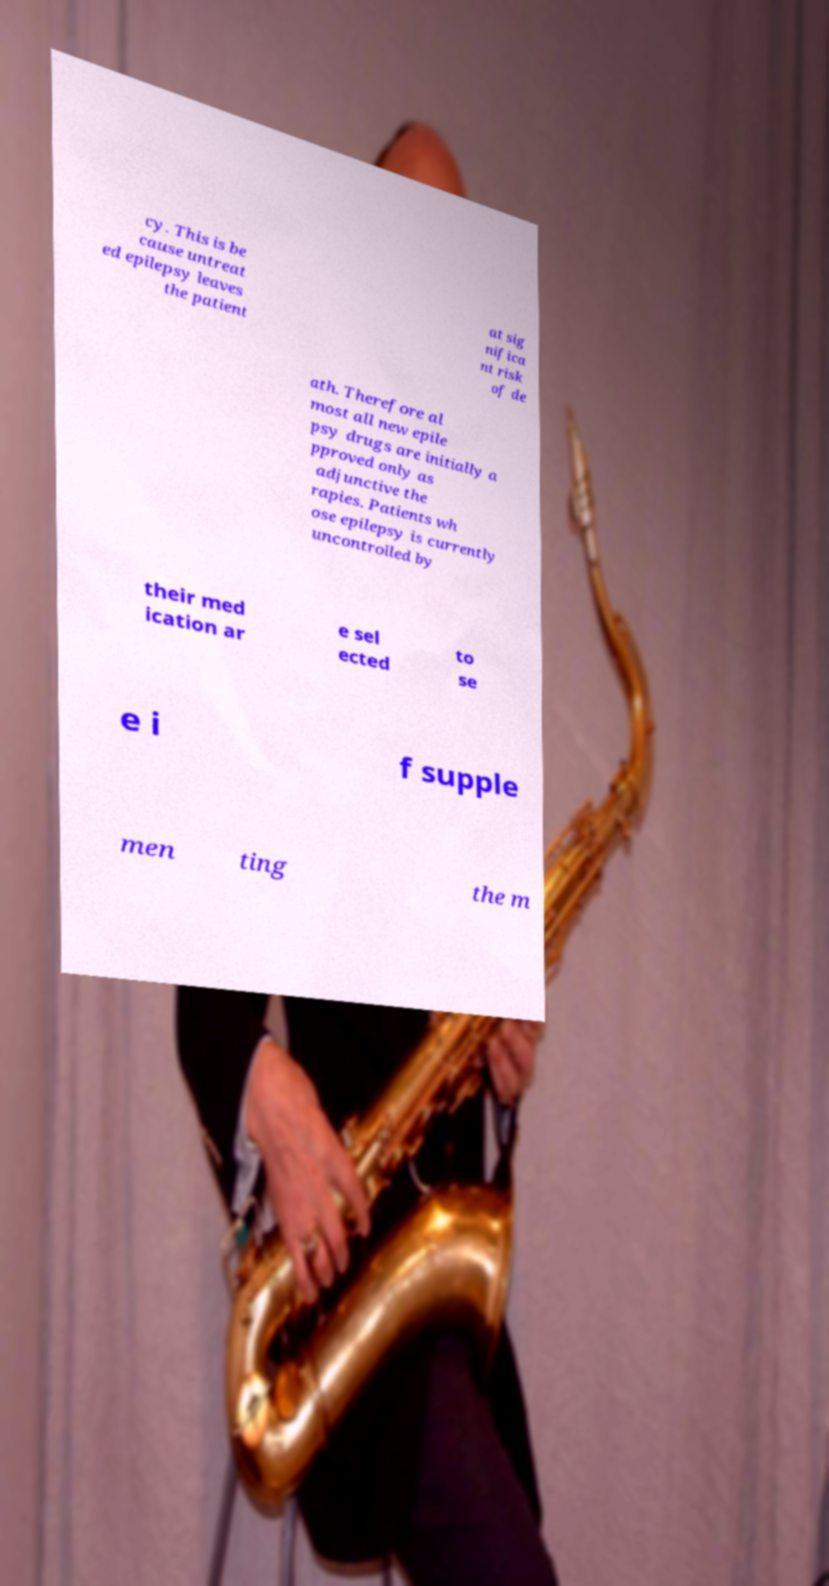What messages or text are displayed in this image? I need them in a readable, typed format. cy. This is be cause untreat ed epilepsy leaves the patient at sig nifica nt risk of de ath. Therefore al most all new epile psy drugs are initially a pproved only as adjunctive the rapies. Patients wh ose epilepsy is currently uncontrolled by their med ication ar e sel ected to se e i f supple men ting the m 